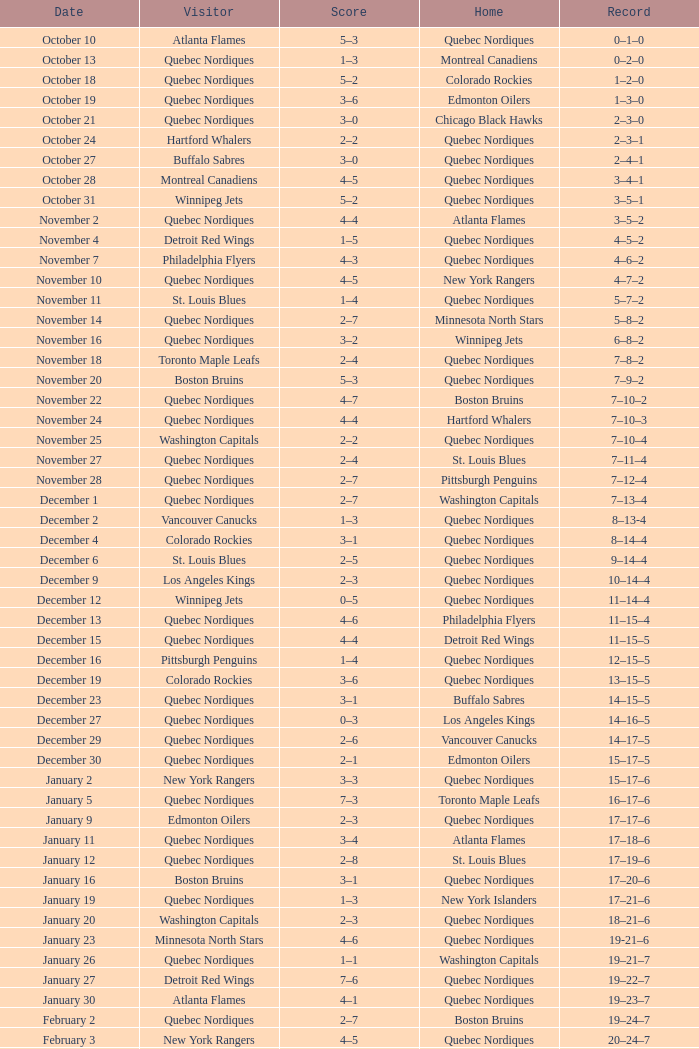Which house has a history of 16 wins, 17 losses, and 6 draws? Toronto Maple Leafs. Could you help me parse every detail presented in this table? {'header': ['Date', 'Visitor', 'Score', 'Home', 'Record'], 'rows': [['October 10', 'Atlanta Flames', '5–3', 'Quebec Nordiques', '0–1–0'], ['October 13', 'Quebec Nordiques', '1–3', 'Montreal Canadiens', '0–2–0'], ['October 18', 'Quebec Nordiques', '5–2', 'Colorado Rockies', '1–2–0'], ['October 19', 'Quebec Nordiques', '3–6', 'Edmonton Oilers', '1–3–0'], ['October 21', 'Quebec Nordiques', '3–0', 'Chicago Black Hawks', '2–3–0'], ['October 24', 'Hartford Whalers', '2–2', 'Quebec Nordiques', '2–3–1'], ['October 27', 'Buffalo Sabres', '3–0', 'Quebec Nordiques', '2–4–1'], ['October 28', 'Montreal Canadiens', '4–5', 'Quebec Nordiques', '3–4–1'], ['October 31', 'Winnipeg Jets', '5–2', 'Quebec Nordiques', '3–5–1'], ['November 2', 'Quebec Nordiques', '4–4', 'Atlanta Flames', '3–5–2'], ['November 4', 'Detroit Red Wings', '1–5', 'Quebec Nordiques', '4–5–2'], ['November 7', 'Philadelphia Flyers', '4–3', 'Quebec Nordiques', '4–6–2'], ['November 10', 'Quebec Nordiques', '4–5', 'New York Rangers', '4–7–2'], ['November 11', 'St. Louis Blues', '1–4', 'Quebec Nordiques', '5–7–2'], ['November 14', 'Quebec Nordiques', '2–7', 'Minnesota North Stars', '5–8–2'], ['November 16', 'Quebec Nordiques', '3–2', 'Winnipeg Jets', '6–8–2'], ['November 18', 'Toronto Maple Leafs', '2–4', 'Quebec Nordiques', '7–8–2'], ['November 20', 'Boston Bruins', '5–3', 'Quebec Nordiques', '7–9–2'], ['November 22', 'Quebec Nordiques', '4–7', 'Boston Bruins', '7–10–2'], ['November 24', 'Quebec Nordiques', '4–4', 'Hartford Whalers', '7–10–3'], ['November 25', 'Washington Capitals', '2–2', 'Quebec Nordiques', '7–10–4'], ['November 27', 'Quebec Nordiques', '2–4', 'St. Louis Blues', '7–11–4'], ['November 28', 'Quebec Nordiques', '2–7', 'Pittsburgh Penguins', '7–12–4'], ['December 1', 'Quebec Nordiques', '2–7', 'Washington Capitals', '7–13–4'], ['December 2', 'Vancouver Canucks', '1–3', 'Quebec Nordiques', '8–13-4'], ['December 4', 'Colorado Rockies', '3–1', 'Quebec Nordiques', '8–14–4'], ['December 6', 'St. Louis Blues', '2–5', 'Quebec Nordiques', '9–14–4'], ['December 9', 'Los Angeles Kings', '2–3', 'Quebec Nordiques', '10–14–4'], ['December 12', 'Winnipeg Jets', '0–5', 'Quebec Nordiques', '11–14–4'], ['December 13', 'Quebec Nordiques', '4–6', 'Philadelphia Flyers', '11–15–4'], ['December 15', 'Quebec Nordiques', '4–4', 'Detroit Red Wings', '11–15–5'], ['December 16', 'Pittsburgh Penguins', '1–4', 'Quebec Nordiques', '12–15–5'], ['December 19', 'Colorado Rockies', '3–6', 'Quebec Nordiques', '13–15–5'], ['December 23', 'Quebec Nordiques', '3–1', 'Buffalo Sabres', '14–15–5'], ['December 27', 'Quebec Nordiques', '0–3', 'Los Angeles Kings', '14–16–5'], ['December 29', 'Quebec Nordiques', '2–6', 'Vancouver Canucks', '14–17–5'], ['December 30', 'Quebec Nordiques', '2–1', 'Edmonton Oilers', '15–17–5'], ['January 2', 'New York Rangers', '3–3', 'Quebec Nordiques', '15–17–6'], ['January 5', 'Quebec Nordiques', '7–3', 'Toronto Maple Leafs', '16–17–6'], ['January 9', 'Edmonton Oilers', '2–3', 'Quebec Nordiques', '17–17–6'], ['January 11', 'Quebec Nordiques', '3–4', 'Atlanta Flames', '17–18–6'], ['January 12', 'Quebec Nordiques', '2–8', 'St. Louis Blues', '17–19–6'], ['January 16', 'Boston Bruins', '3–1', 'Quebec Nordiques', '17–20–6'], ['January 19', 'Quebec Nordiques', '1–3', 'New York Islanders', '17–21–6'], ['January 20', 'Washington Capitals', '2–3', 'Quebec Nordiques', '18–21–6'], ['January 23', 'Minnesota North Stars', '4–6', 'Quebec Nordiques', '19-21–6'], ['January 26', 'Quebec Nordiques', '1–1', 'Washington Capitals', '19–21–7'], ['January 27', 'Detroit Red Wings', '7–6', 'Quebec Nordiques', '19–22–7'], ['January 30', 'Atlanta Flames', '4–1', 'Quebec Nordiques', '19–23–7'], ['February 2', 'Quebec Nordiques', '2–7', 'Boston Bruins', '19–24–7'], ['February 3', 'New York Rangers', '4–5', 'Quebec Nordiques', '20–24–7'], ['February 6', 'Chicago Black Hawks', '3–3', 'Quebec Nordiques', '20–24–8'], ['February 9', 'Quebec Nordiques', '0–5', 'New York Islanders', '20–25–8'], ['February 10', 'Quebec Nordiques', '1–3', 'New York Rangers', '20–26–8'], ['February 14', 'Quebec Nordiques', '1–5', 'Montreal Canadiens', '20–27–8'], ['February 17', 'Quebec Nordiques', '5–6', 'Winnipeg Jets', '20–28–8'], ['February 18', 'Quebec Nordiques', '2–6', 'Minnesota North Stars', '20–29–8'], ['February 19', 'Buffalo Sabres', '3–1', 'Quebec Nordiques', '20–30–8'], ['February 23', 'Quebec Nordiques', '1–2', 'Pittsburgh Penguins', '20–31–8'], ['February 24', 'Pittsburgh Penguins', '0–2', 'Quebec Nordiques', '21–31–8'], ['February 26', 'Hartford Whalers', '5–9', 'Quebec Nordiques', '22–31–8'], ['February 27', 'New York Islanders', '5–3', 'Quebec Nordiques', '22–32–8'], ['March 2', 'Los Angeles Kings', '4–3', 'Quebec Nordiques', '22–33–8'], ['March 5', 'Minnesota North Stars', '3-3', 'Quebec Nordiques', '22–33–9'], ['March 8', 'Quebec Nordiques', '2–3', 'Toronto Maple Leafs', '22–34–9'], ['March 9', 'Toronto Maple Leafs', '4–5', 'Quebec Nordiques', '23–34-9'], ['March 12', 'Edmonton Oilers', '6–3', 'Quebec Nordiques', '23–35–9'], ['March 16', 'Vancouver Canucks', '3–2', 'Quebec Nordiques', '23–36–9'], ['March 19', 'Quebec Nordiques', '2–5', 'Chicago Black Hawks', '23–37–9'], ['March 20', 'Quebec Nordiques', '6–2', 'Colorado Rockies', '24–37–9'], ['March 22', 'Quebec Nordiques', '1-4', 'Los Angeles Kings', '24–38-9'], ['March 23', 'Quebec Nordiques', '6–2', 'Vancouver Canucks', '25–38–9'], ['March 26', 'Chicago Black Hawks', '7–2', 'Quebec Nordiques', '25–39–9'], ['March 27', 'Quebec Nordiques', '2–5', 'Philadelphia Flyers', '25–40–9'], ['March 29', 'Quebec Nordiques', '7–9', 'Detroit Red Wings', '25–41–9'], ['March 30', 'New York Islanders', '9–6', 'Quebec Nordiques', '25–42–9'], ['April 1', 'Philadelphia Flyers', '3–3', 'Quebec Nordiques', '25–42–10'], ['April 3', 'Quebec Nordiques', '3–8', 'Buffalo Sabres', '25–43–10'], ['April 4', 'Quebec Nordiques', '2–9', 'Hartford Whalers', '25–44–10'], ['April 6', 'Montreal Canadiens', '4–4', 'Quebec Nordiques', '25–44–11']]} 